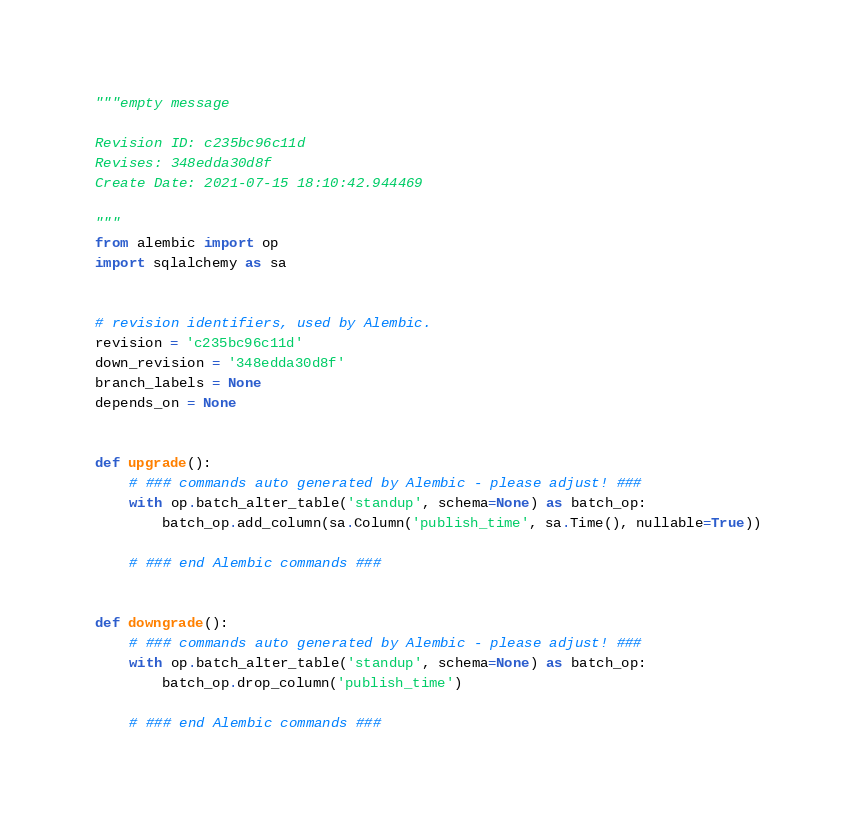<code> <loc_0><loc_0><loc_500><loc_500><_Python_>"""empty message

Revision ID: c235bc96c11d
Revises: 348edda30d8f
Create Date: 2021-07-15 18:10:42.944469

"""
from alembic import op
import sqlalchemy as sa


# revision identifiers, used by Alembic.
revision = 'c235bc96c11d'
down_revision = '348edda30d8f'
branch_labels = None
depends_on = None


def upgrade():
    # ### commands auto generated by Alembic - please adjust! ###
    with op.batch_alter_table('standup', schema=None) as batch_op:
        batch_op.add_column(sa.Column('publish_time', sa.Time(), nullable=True))

    # ### end Alembic commands ###


def downgrade():
    # ### commands auto generated by Alembic - please adjust! ###
    with op.batch_alter_table('standup', schema=None) as batch_op:
        batch_op.drop_column('publish_time')

    # ### end Alembic commands ###
</code> 